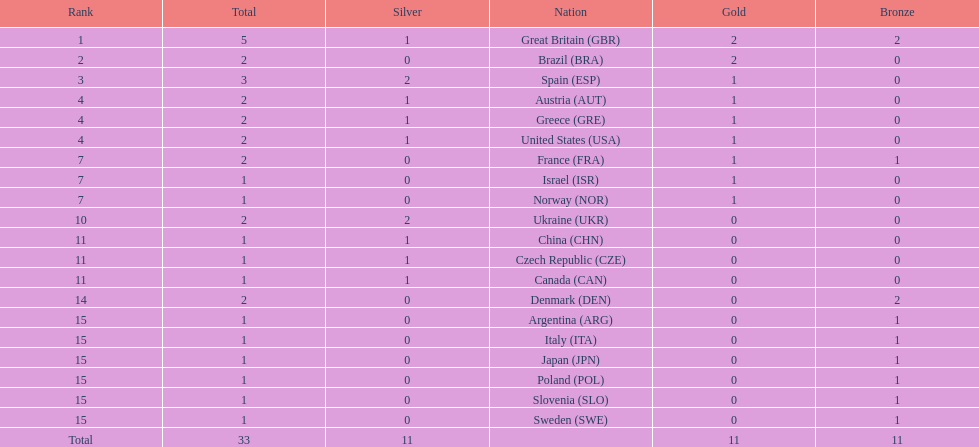What nation was next to great britain in total medal count? Spain. 